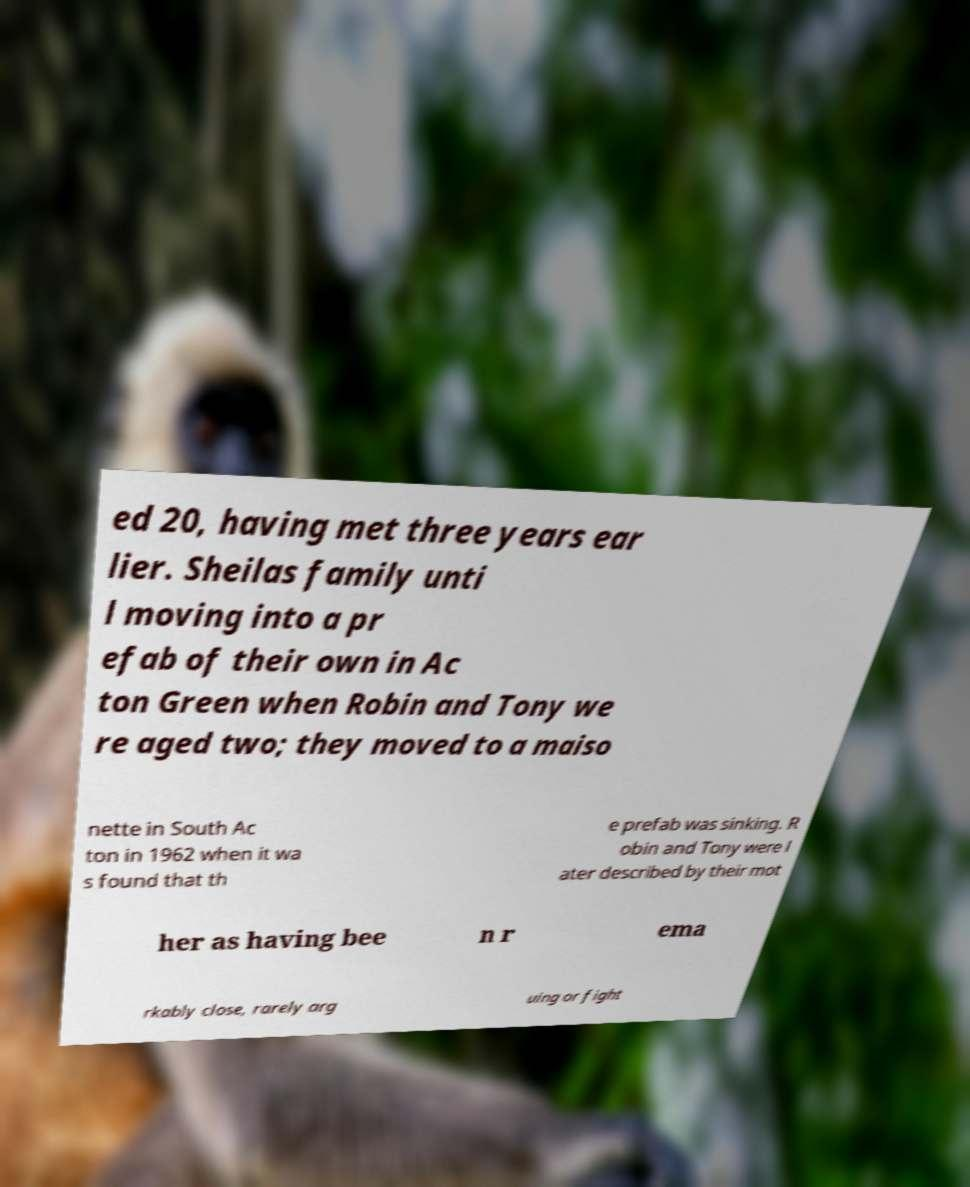Can you accurately transcribe the text from the provided image for me? ed 20, having met three years ear lier. Sheilas family unti l moving into a pr efab of their own in Ac ton Green when Robin and Tony we re aged two; they moved to a maiso nette in South Ac ton in 1962 when it wa s found that th e prefab was sinking. R obin and Tony were l ater described by their mot her as having bee n r ema rkably close, rarely arg uing or fight 